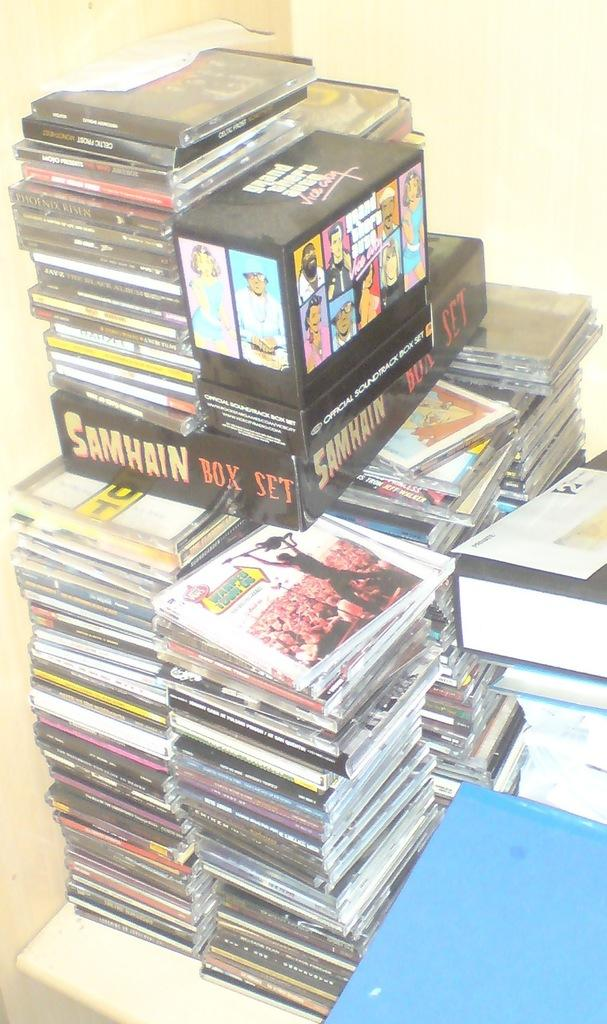<image>
Present a compact description of the photo's key features. Stacks of CD's from the Samhain Box Set. 